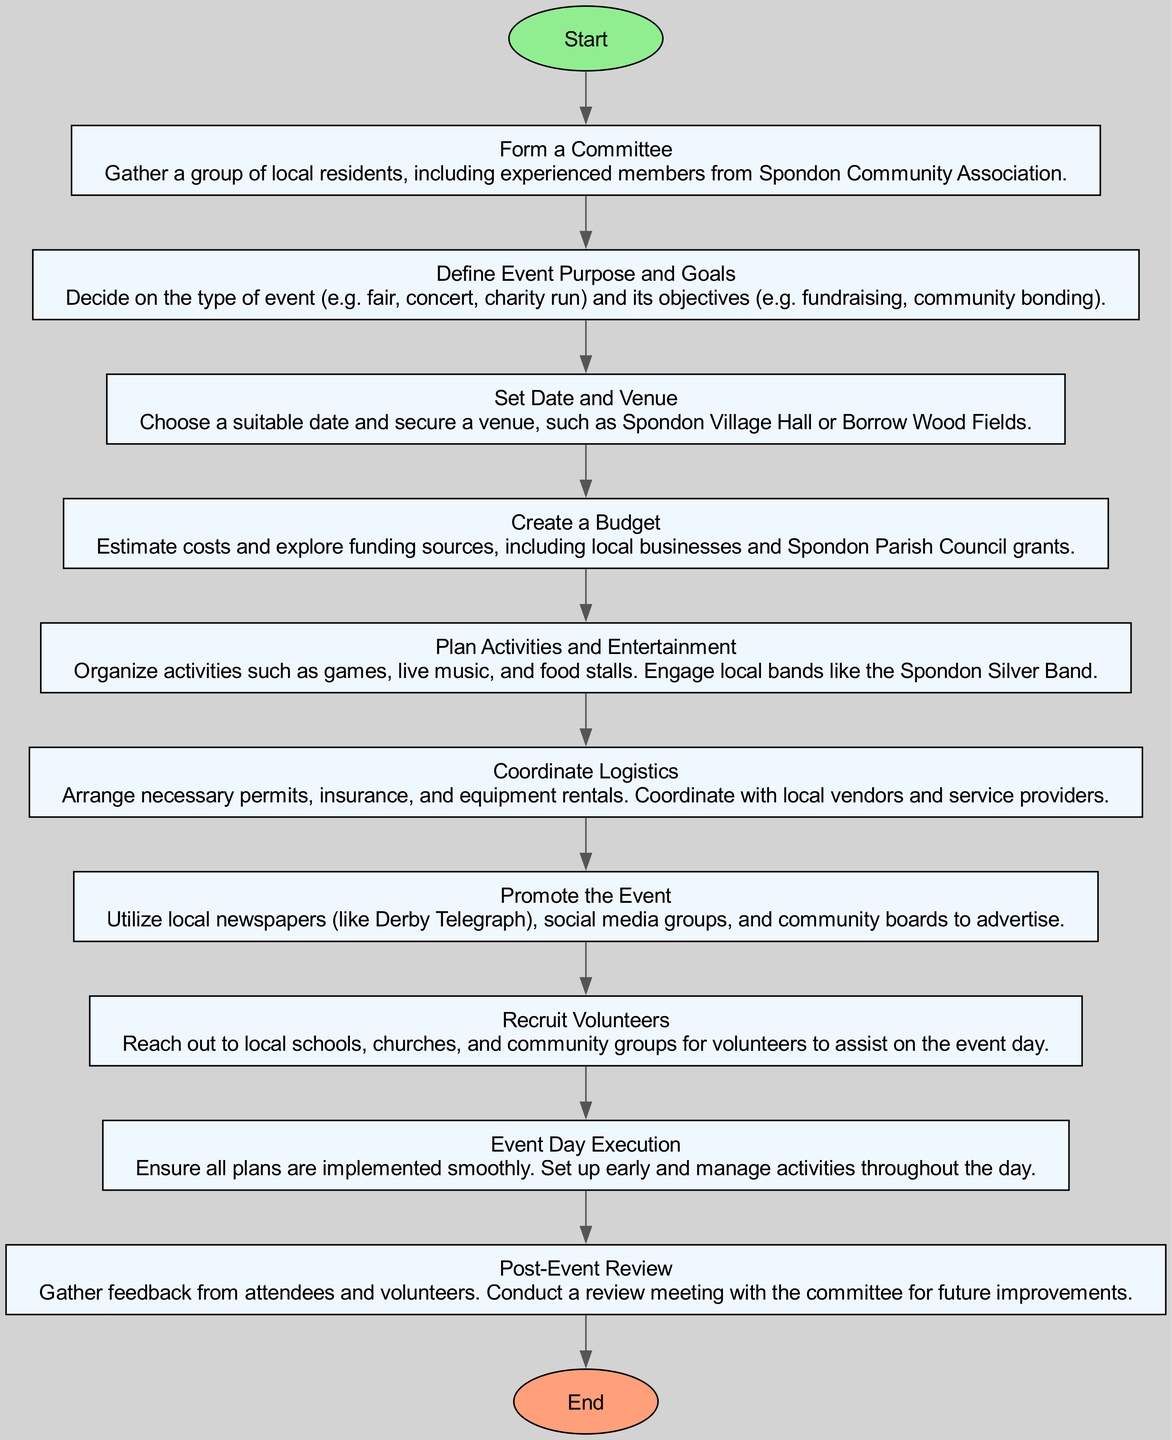What is the first step in the event planning process? The first step listed in the flowchart is "Form a Committee". This can be found directly after the "Start" node, indicating what should be done first.
Answer: Form a Committee How many steps are there in the event planning process? Counting the individual steps listed in the flowchart from "Step1" to "Step10," there are a total of 10 steps in the process.
Answer: 10 What is the purpose of the "Define Event Purpose and Goals" step? The flowchart indicates that this step decides on the type of event and its objectives. This information is clearly described in the box for "Step2."
Answer: Decide on the type of event and its objectives Which step involves securing a venue? The step related to securing a venue is "Set Date and Venue," which is "Step3". This can be identified as the step that follows after defining the event’s purpose and goals.
Answer: Set Date and Venue What is the last step in the planning process? The last step in the flowchart is "Post-Event Review." It is linked to the final execution of the event, as denoted by the connection from "Step10" to "End."
Answer: Post-Event Review Which steps directly precede the "Event Day Execution"? The step that directly precedes "Event Day Execution" is "Recruit Volunteers," which is "Step8." This shows that planning and recruiting volunteers is crucial just before the execution phase.
Answer: Recruit Volunteers What type of promotions are suggested for the event? The flowchart suggests utilizing local newspapers, social media, and community boards for promotion during the "Promote the Event" step, which is "Step7."
Answer: Local newspapers, social media, community boards What is required for coordinating logistics? The step "Coordinate Logistics" details that necessary permits, insurance, and equipment rentals must be arranged, highlighting the logistical considerations needed before the event execution.
Answer: Necessary permits, insurance, equipment rentals 